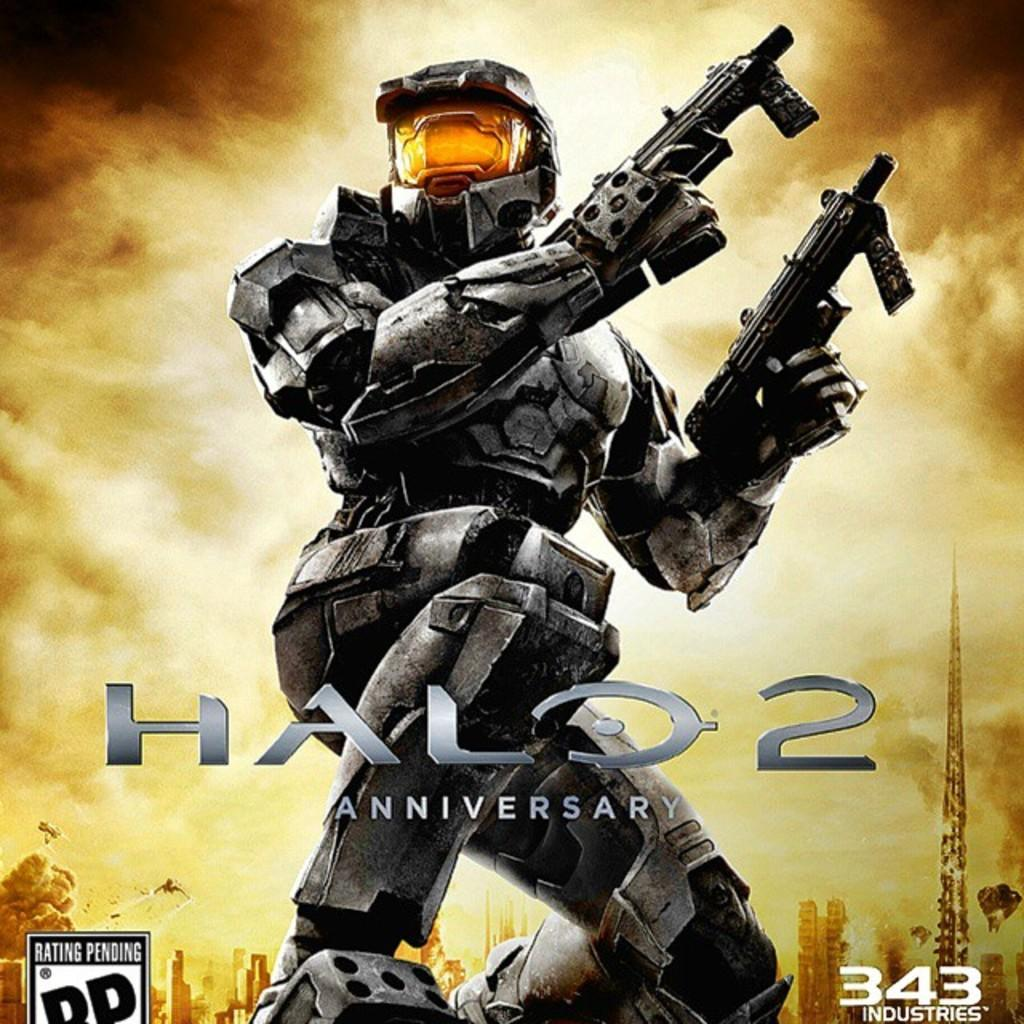<image>
Present a compact description of the photo's key features. Cover of a video game named Halo 2 Anniversary. 